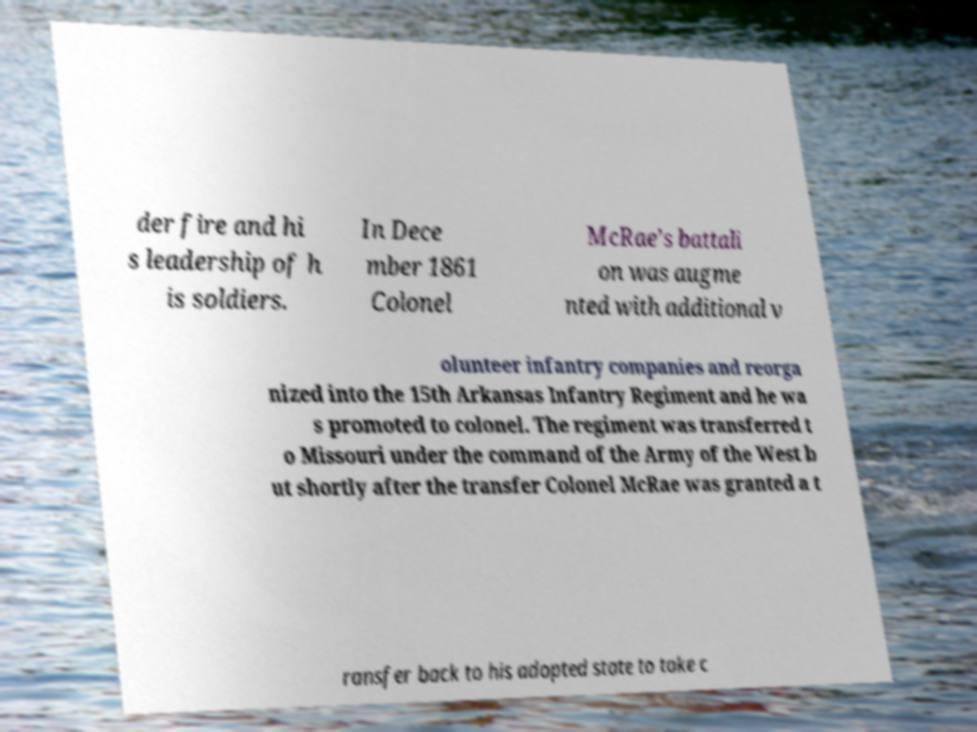Can you read and provide the text displayed in the image?This photo seems to have some interesting text. Can you extract and type it out for me? der fire and hi s leadership of h is soldiers. In Dece mber 1861 Colonel McRae’s battali on was augme nted with additional v olunteer infantry companies and reorga nized into the 15th Arkansas Infantry Regiment and he wa s promoted to colonel. The regiment was transferred t o Missouri under the command of the Army of the West b ut shortly after the transfer Colonel McRae was granted a t ransfer back to his adopted state to take c 